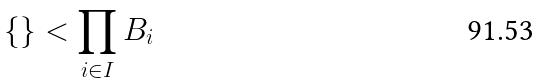Convert formula to latex. <formula><loc_0><loc_0><loc_500><loc_500>\{ \} < \prod _ { i \in I } B _ { i }</formula> 